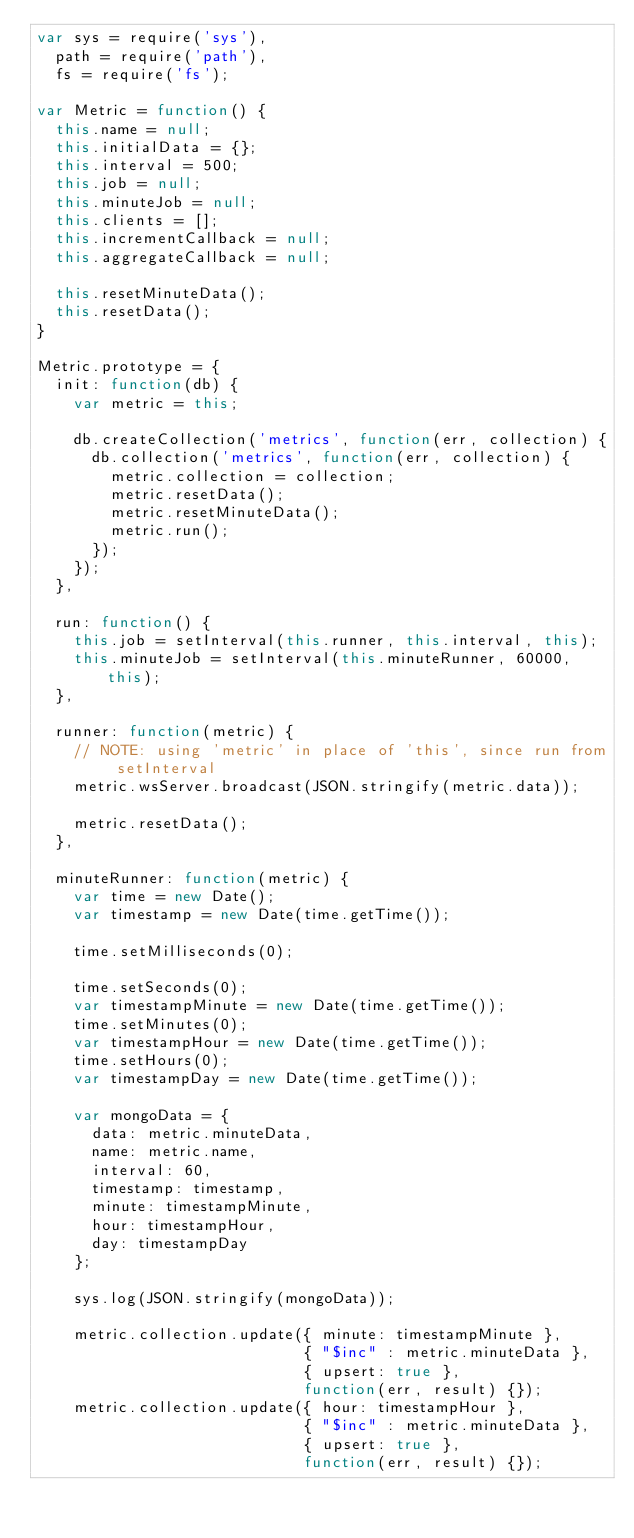<code> <loc_0><loc_0><loc_500><loc_500><_JavaScript_>var sys = require('sys'),
  path = require('path'),
  fs = require('fs');

var Metric = function() {
  this.name = null;
  this.initialData = {};
  this.interval = 500;
  this.job = null;
  this.minuteJob = null;
  this.clients = [];
  this.incrementCallback = null;
  this.aggregateCallback = null;

  this.resetMinuteData();
  this.resetData();
}

Metric.prototype = {
  init: function(db) {
    var metric = this;

    db.createCollection('metrics', function(err, collection) {
      db.collection('metrics', function(err, collection) {
        metric.collection = collection;
        metric.resetData();
        metric.resetMinuteData();
        metric.run();
      });
    });
  },

  run: function() {
    this.job = setInterval(this.runner, this.interval, this);
    this.minuteJob = setInterval(this.minuteRunner, 60000, this);
  },

  runner: function(metric) {
    // NOTE: using 'metric' in place of 'this', since run from setInterval
    metric.wsServer.broadcast(JSON.stringify(metric.data));

    metric.resetData();
  },

  minuteRunner: function(metric) {
    var time = new Date();
    var timestamp = new Date(time.getTime());

    time.setMilliseconds(0);

    time.setSeconds(0);
    var timestampMinute = new Date(time.getTime());
    time.setMinutes(0);
    var timestampHour = new Date(time.getTime());
    time.setHours(0);
    var timestampDay = new Date(time.getTime());

    var mongoData = {
      data: metric.minuteData,
      name: metric.name,
      interval: 60,
      timestamp: timestamp,
      minute: timestampMinute,
      hour: timestampHour,
      day: timestampDay
    };

    sys.log(JSON.stringify(mongoData));

    metric.collection.update({ minute: timestampMinute },
                             { "$inc" : metric.minuteData },
                             { upsert: true },
                             function(err, result) {});
    metric.collection.update({ hour: timestampHour },
                             { "$inc" : metric.minuteData },
                             { upsert: true },
                             function(err, result) {});</code> 